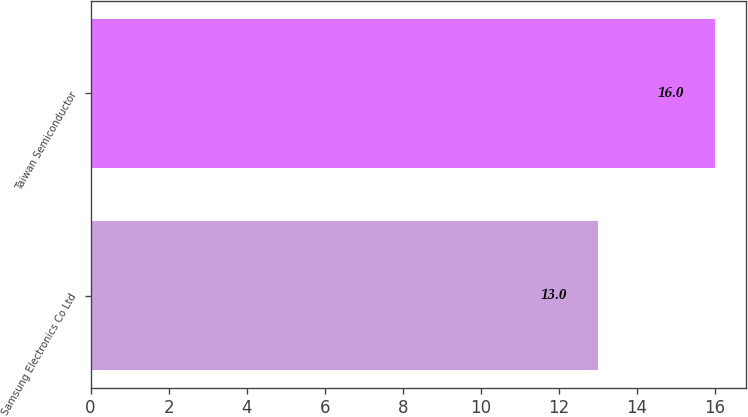Convert chart to OTSL. <chart><loc_0><loc_0><loc_500><loc_500><bar_chart><fcel>Samsung Electronics Co Ltd<fcel>Taiwan Semiconductor<nl><fcel>13<fcel>16<nl></chart> 